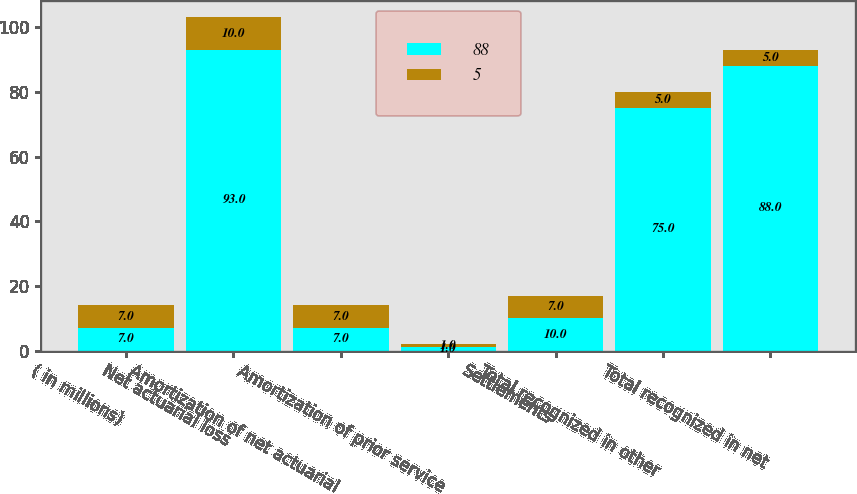Convert chart to OTSL. <chart><loc_0><loc_0><loc_500><loc_500><stacked_bar_chart><ecel><fcel>( in millions)<fcel>Net actuarial loss<fcel>Amortization of net actuarial<fcel>Amortization of prior service<fcel>Settlements<fcel>Total recognized in other<fcel>Total recognized in net<nl><fcel>88<fcel>7<fcel>93<fcel>7<fcel>1<fcel>10<fcel>75<fcel>88<nl><fcel>5<fcel>7<fcel>10<fcel>7<fcel>1<fcel>7<fcel>5<fcel>5<nl></chart> 